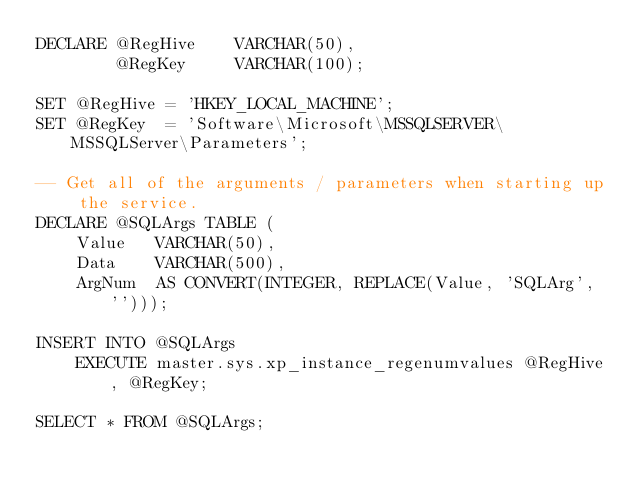<code> <loc_0><loc_0><loc_500><loc_500><_SQL_>DECLARE @RegHive    VARCHAR(50),
        @RegKey     VARCHAR(100);
 
SET @RegHive = 'HKEY_LOCAL_MACHINE';
SET @RegKey  = 'Software\Microsoft\MSSQLSERVER\MSSQLServer\Parameters';
 
-- Get all of the arguments / parameters when starting up the service.
DECLARE @SQLArgs TABLE (
    Value   VARCHAR(50),
    Data    VARCHAR(500),
    ArgNum  AS CONVERT(INTEGER, REPLACE(Value, 'SQLArg', '')));
 
INSERT INTO @SQLArgs
    EXECUTE master.sys.xp_instance_regenumvalues @RegHive, @RegKey;
 
SELECT * FROM @SQLArgs;</code> 